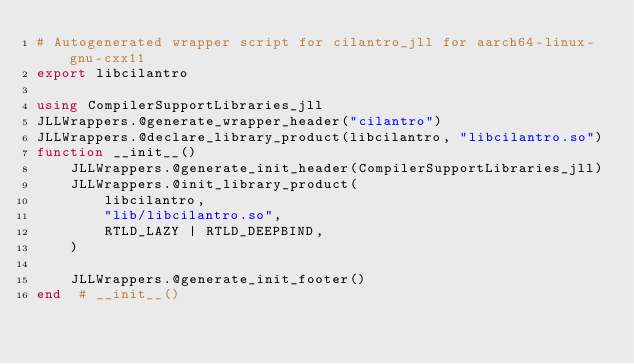<code> <loc_0><loc_0><loc_500><loc_500><_Julia_># Autogenerated wrapper script for cilantro_jll for aarch64-linux-gnu-cxx11
export libcilantro

using CompilerSupportLibraries_jll
JLLWrappers.@generate_wrapper_header("cilantro")
JLLWrappers.@declare_library_product(libcilantro, "libcilantro.so")
function __init__()
    JLLWrappers.@generate_init_header(CompilerSupportLibraries_jll)
    JLLWrappers.@init_library_product(
        libcilantro,
        "lib/libcilantro.so",
        RTLD_LAZY | RTLD_DEEPBIND,
    )

    JLLWrappers.@generate_init_footer()
end  # __init__()
</code> 